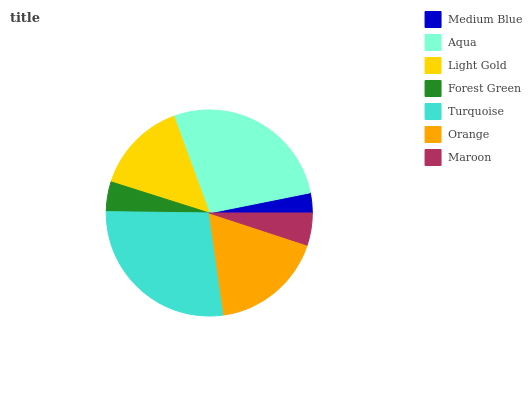Is Medium Blue the minimum?
Answer yes or no. Yes. Is Turquoise the maximum?
Answer yes or no. Yes. Is Aqua the minimum?
Answer yes or no. No. Is Aqua the maximum?
Answer yes or no. No. Is Aqua greater than Medium Blue?
Answer yes or no. Yes. Is Medium Blue less than Aqua?
Answer yes or no. Yes. Is Medium Blue greater than Aqua?
Answer yes or no. No. Is Aqua less than Medium Blue?
Answer yes or no. No. Is Light Gold the high median?
Answer yes or no. Yes. Is Light Gold the low median?
Answer yes or no. Yes. Is Medium Blue the high median?
Answer yes or no. No. Is Medium Blue the low median?
Answer yes or no. No. 